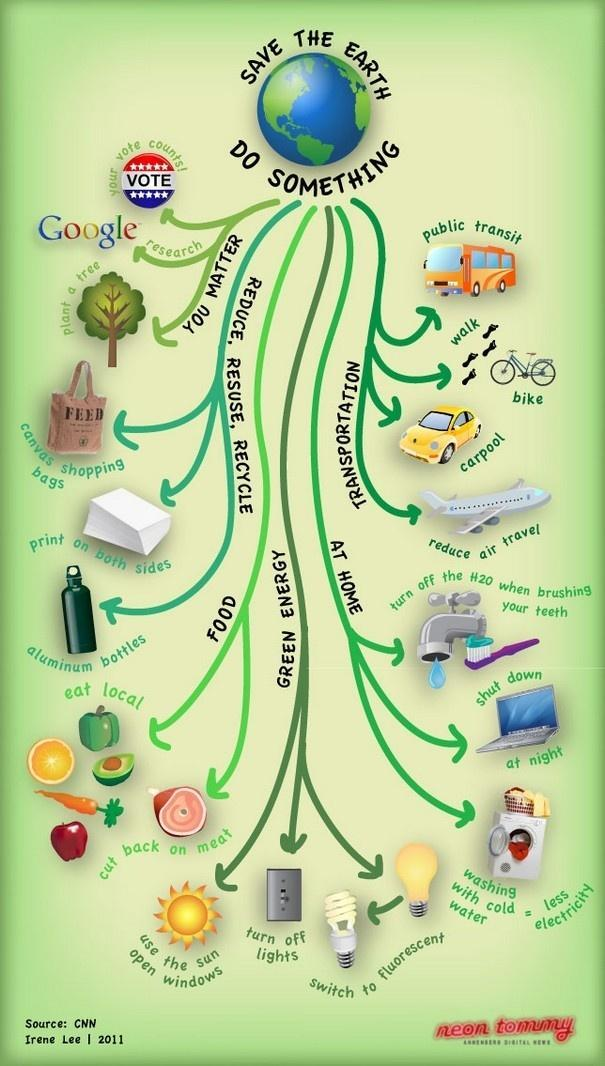Which form of transportation leads to more greenhouse gas emissions, bus, plane, cycle, or car?
Answer the question with a short phrase. plane Which is a source of renewable energy, bulbs, CFL, LED, or sun? sun Which food type increases the carbon footprint, meat, fruits, or vegetables? meat 